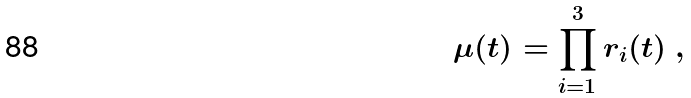Convert formula to latex. <formula><loc_0><loc_0><loc_500><loc_500>\mu ( t ) = \prod _ { i = 1 } ^ { 3 } r _ { i } ( t ) \ ,</formula> 